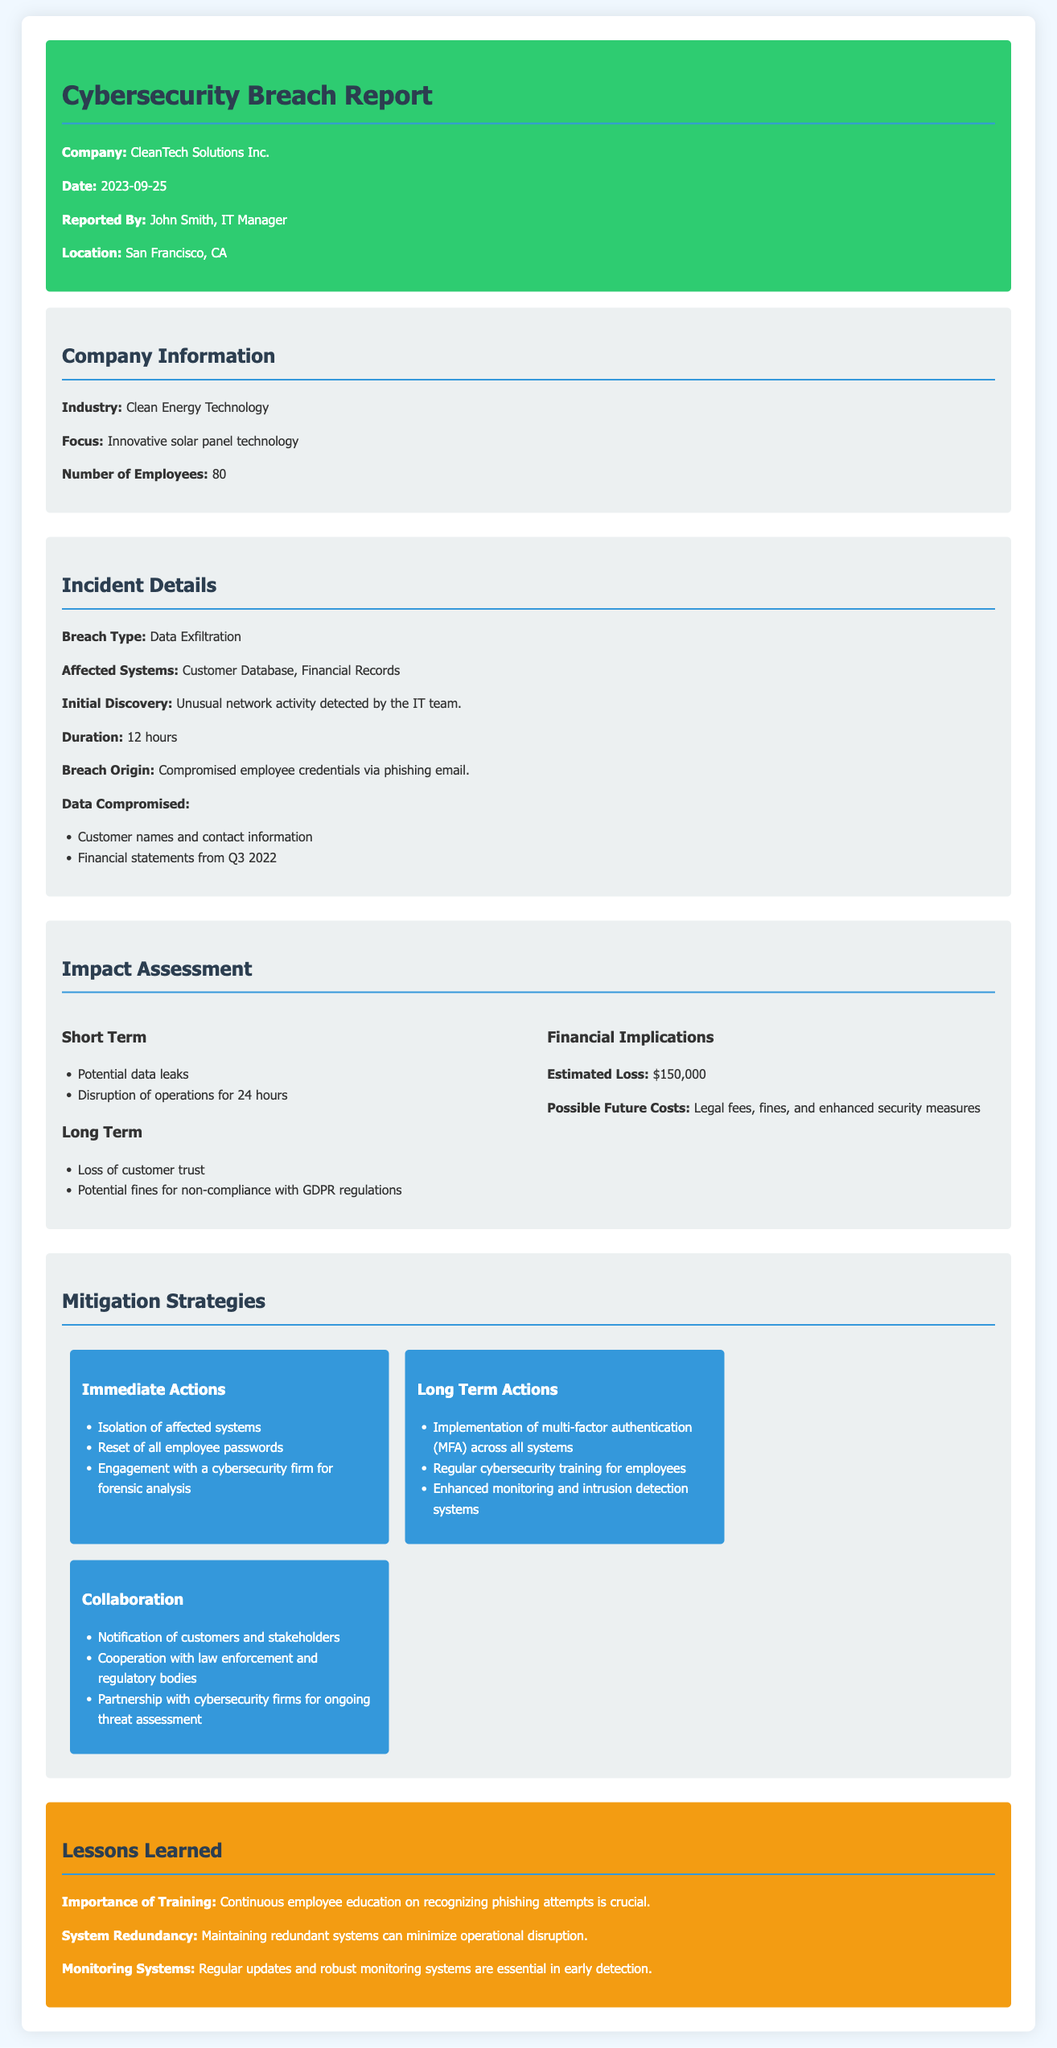What is the date of the report? The date of the report is mentioned in the header section of the document.
Answer: 2023-09-25 Who reported the incident? The person who reported the incident is mentioned under the header section.
Answer: John Smith What type of breach occurred? The type of breach is specified in the incident details section.
Answer: Data Exfiltration How many employees does CleanTech Solutions Inc. have? The number of employees is provided in the company information section.
Answer: 80 What is the estimated loss from the breach? The estimated loss is included in the impact assessment section.
Answer: $150,000 What immediate action was taken post-breach? The document lists immediate actions in the mitigation strategies section.
Answer: Isolation of affected systems What is one long-term action recommended? Long-term actions are specified in the mitigation strategies section.
Answer: Implementation of multi-factor authentication (MFA) across all systems What is a lesson learned from the incident? The lessons learned section outlines key takeaways from the incident response.
Answer: Importance of Training What potential fine is mentioned for non-compliance? The potential fines are referenced in the impact assessment section.
Answer: GDPR regulations 